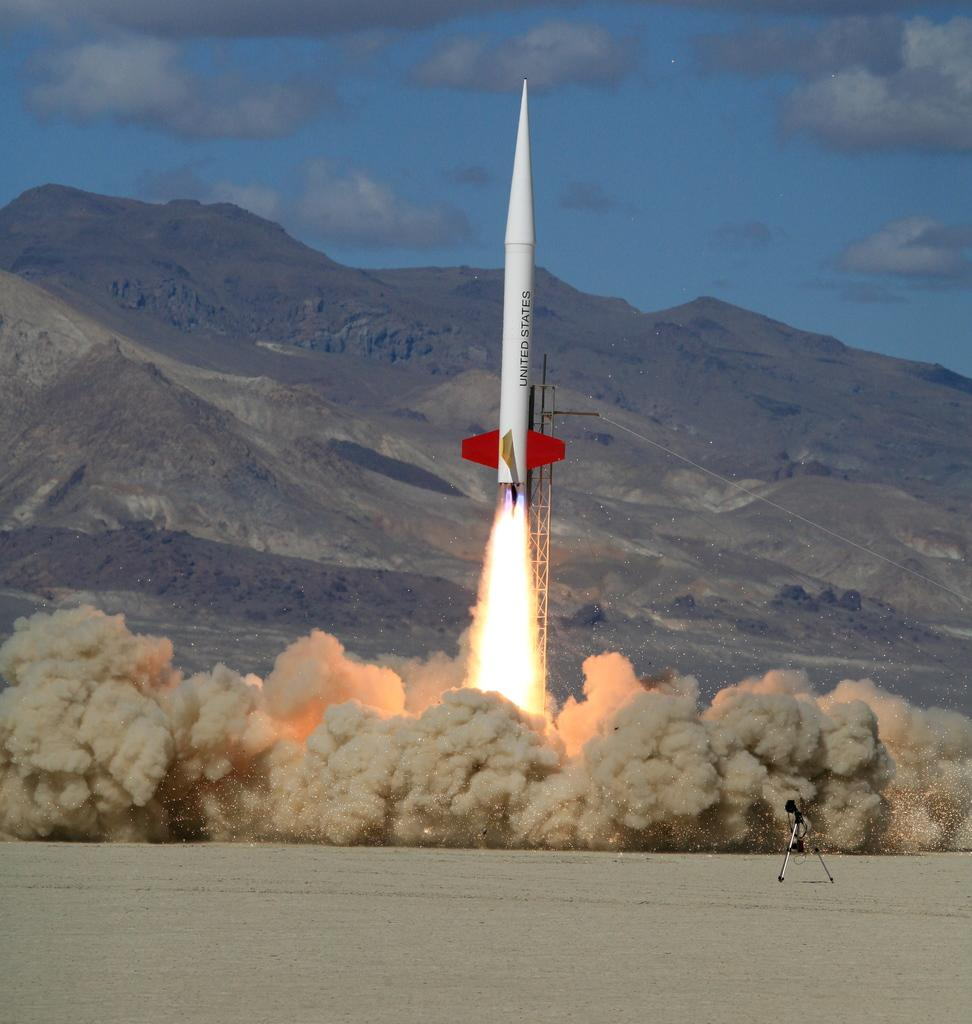<image>
Create a compact narrative representing the image presented. A white rocket with United States embellished on the side shoots up into the sky 